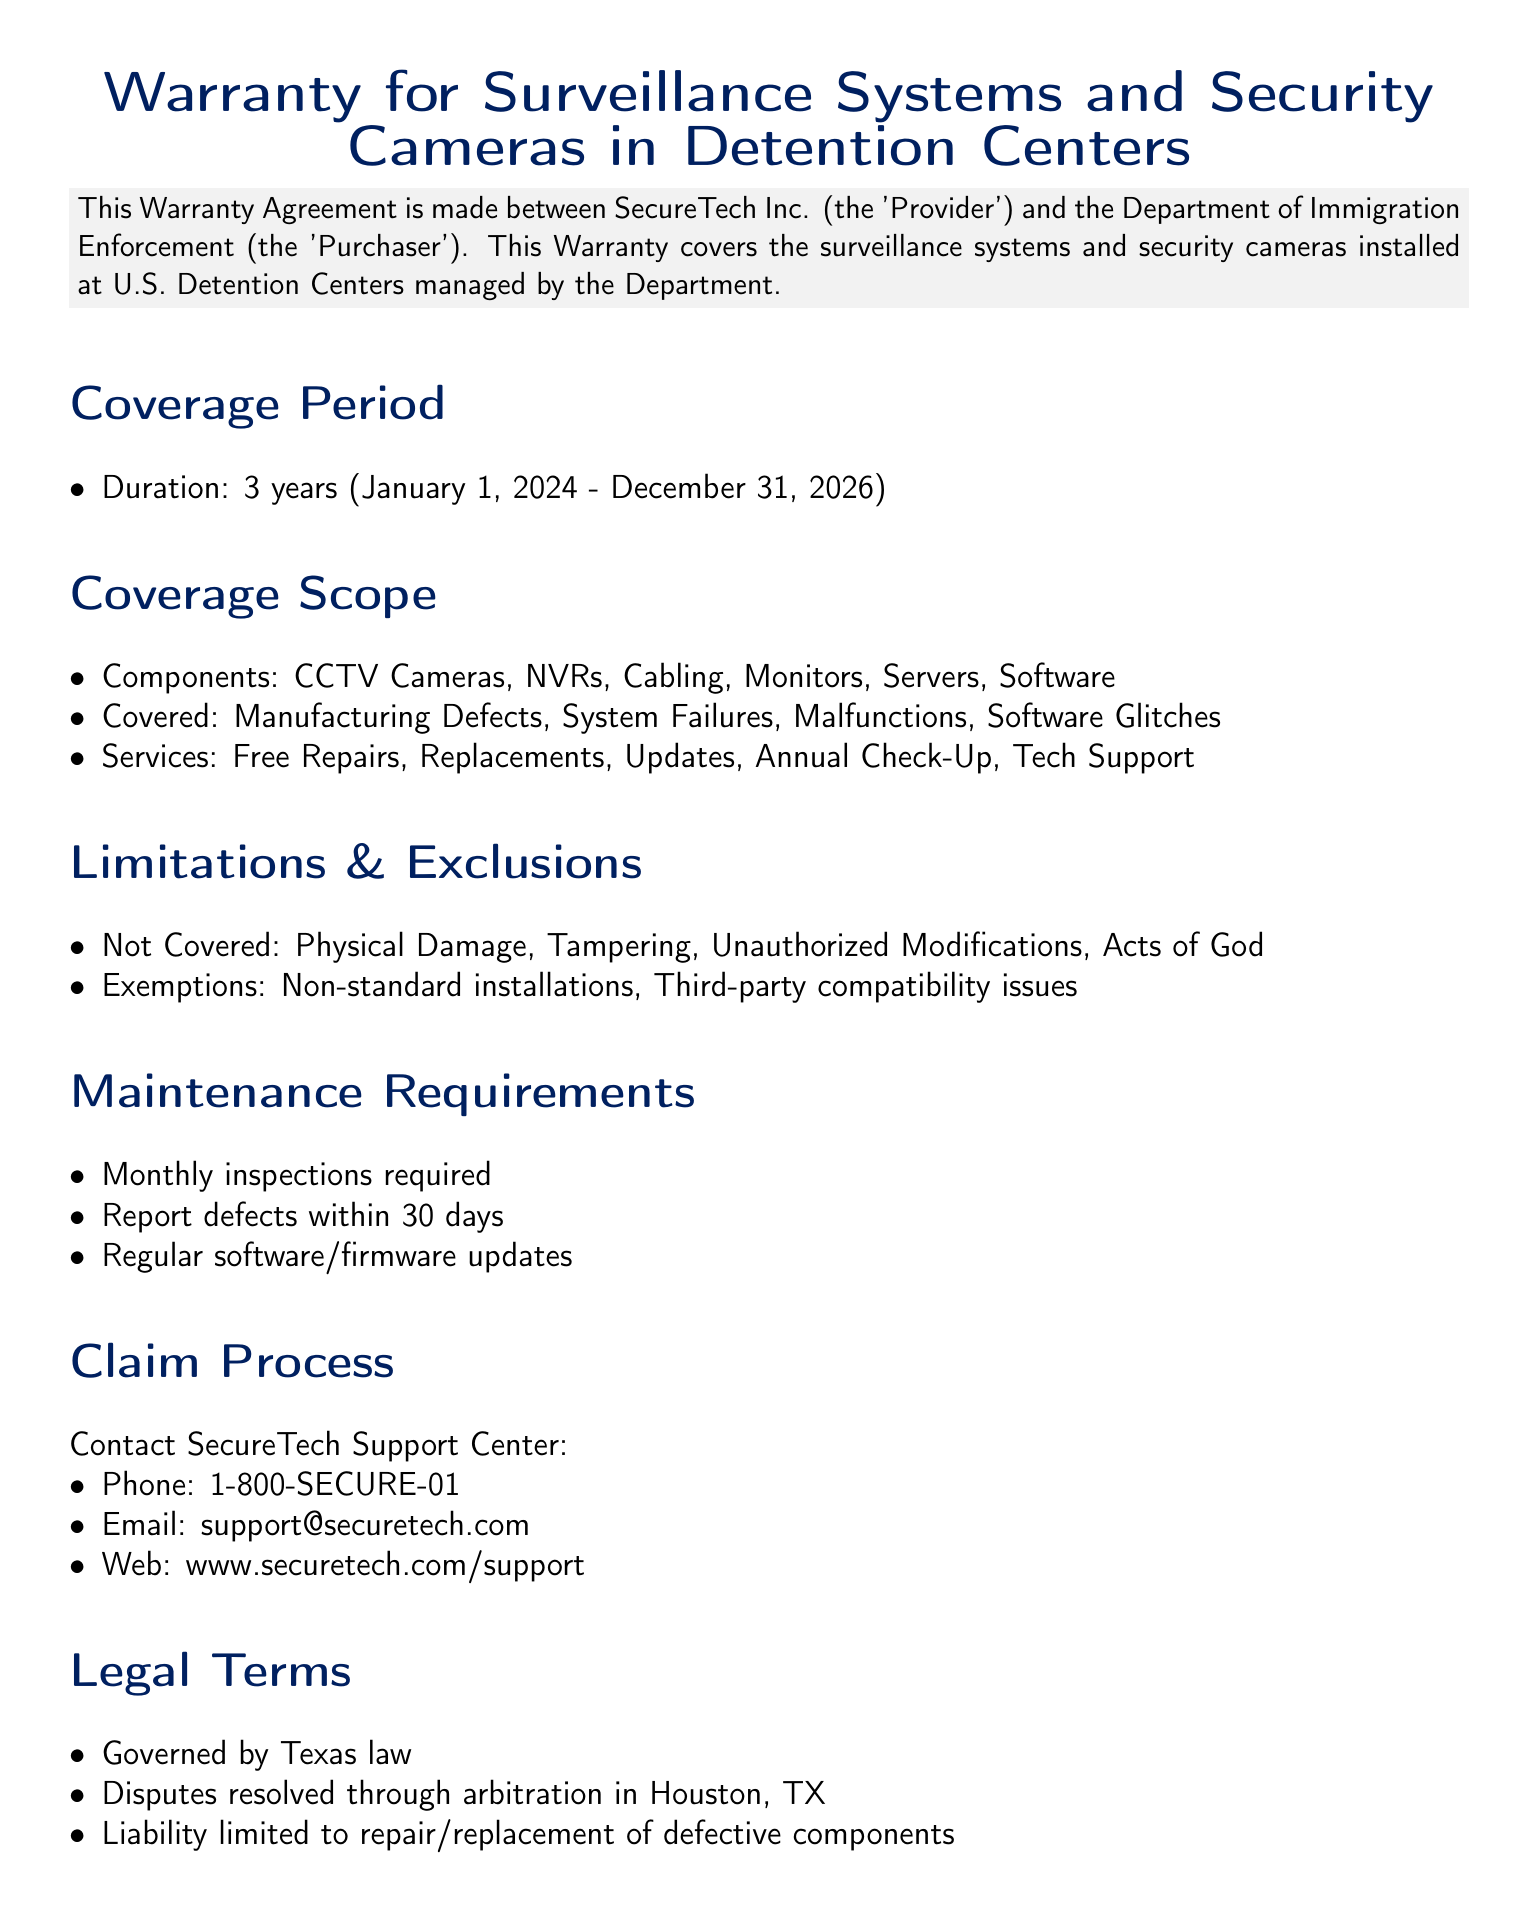What is the coverage period of the warranty? The coverage period is specified in the document, which outlines the start and end dates of the warranty.
Answer: 3 years (January 1, 2024 - December 31, 2026) What services are included in the warranty? The document lists specific services that are covered under the warranty agreement.
Answer: Free Repairs, Replacements, Updates, Annual Check-Up, Tech Support What type of damage is not covered under the warranty? The limitations section of the document specifies what types of damage are not included in the warranty coverage.
Answer: Physical Damage How long do you have to report defects? The maintenance requirements section indicates the timeframe for reporting defects once identified.
Answer: 30 days What is the liability of the Provider? The legal terms section specifies the limits of liability for the Provider as stated in the document.
Answer: Repair/Replacement of defective components Which law governs this warranty agreement? The legal terms section specifies the governing law associated with this warranty agreement.
Answer: Texas law What is the claim process contact phone number? The claim process section provides contact information, including a phone number for claims.
Answer: 1-800-SECURE-01 Who is the Director of Facility Operations for the Purchaser? The document lists the name and title of the individual representing the Purchaser in the warranty agreement.
Answer: Maria Hernandez 